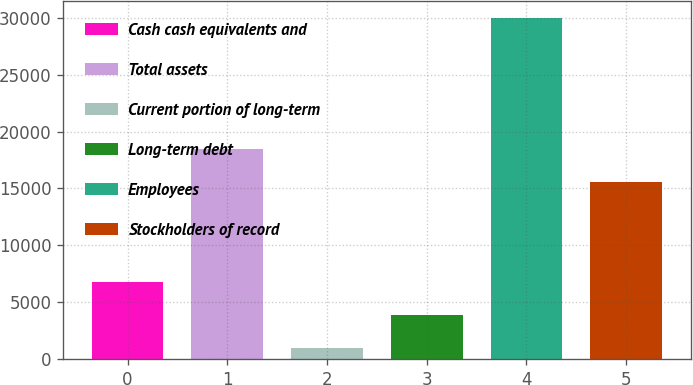<chart> <loc_0><loc_0><loc_500><loc_500><bar_chart><fcel>Cash cash equivalents and<fcel>Total assets<fcel>Current portion of long-term<fcel>Long-term debt<fcel>Employees<fcel>Stockholders of record<nl><fcel>6795.4<fcel>18460.7<fcel>1000<fcel>3897.7<fcel>29977<fcel>15563<nl></chart> 